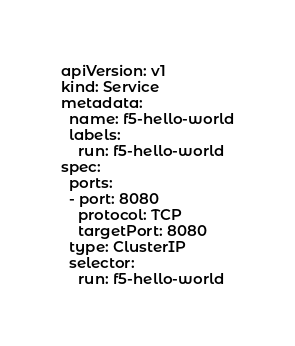<code> <loc_0><loc_0><loc_500><loc_500><_YAML_>apiVersion: v1
kind: Service
metadata:
  name: f5-hello-world
  labels:
    run: f5-hello-world
spec:
  ports:
  - port: 8080
    protocol: TCP
    targetPort: 8080
  type: ClusterIP
  selector:
    run: f5-hello-world
</code> 